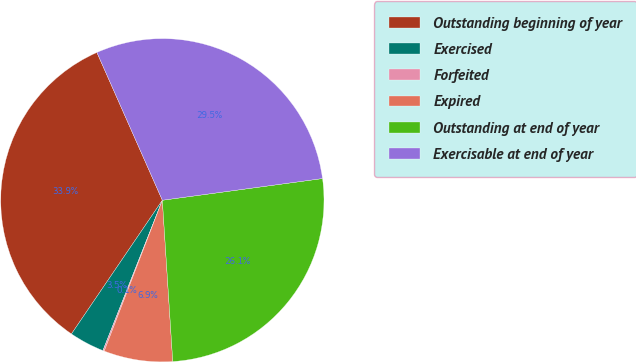<chart> <loc_0><loc_0><loc_500><loc_500><pie_chart><fcel>Outstanding beginning of year<fcel>Exercised<fcel>Forfeited<fcel>Expired<fcel>Outstanding at end of year<fcel>Exercisable at end of year<nl><fcel>33.86%<fcel>3.51%<fcel>0.14%<fcel>6.88%<fcel>26.12%<fcel>29.49%<nl></chart> 